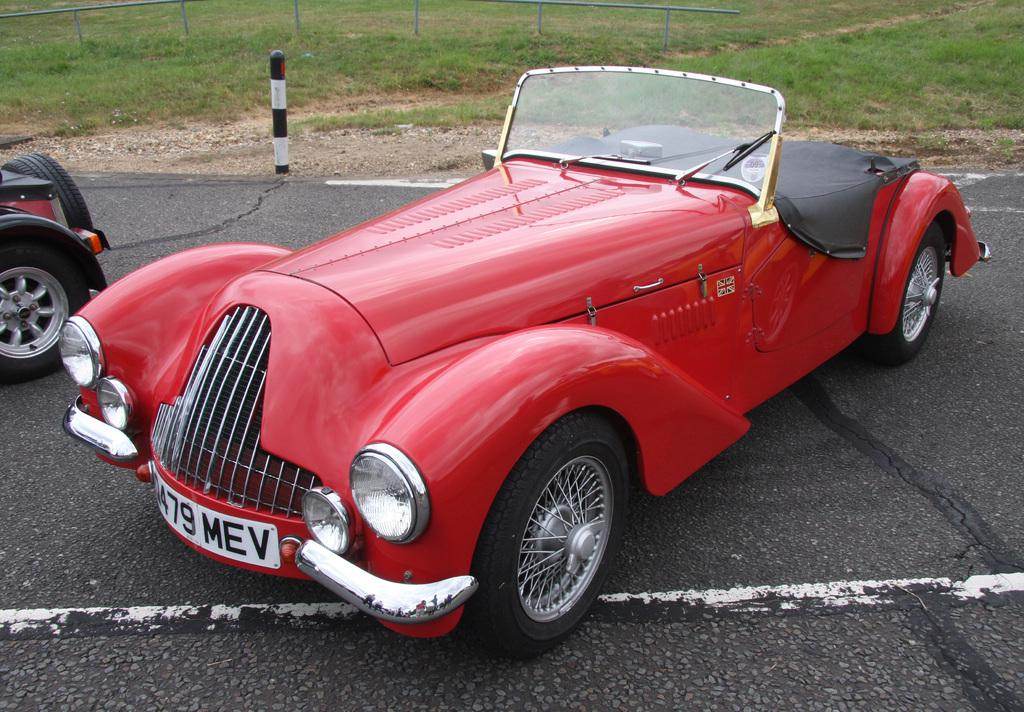What can be seen on the road in the image? There are vehicles on the road in the image. Can you describe one of the vehicles? One of the vehicles is red in color. What is visible in the background of the image? There are poles, grass, and other objects in the background of the image. How many eyes can be seen on the grass in the image? There are no eyes visible on the grass in the image, as grass is a plant and does not have eyes. 